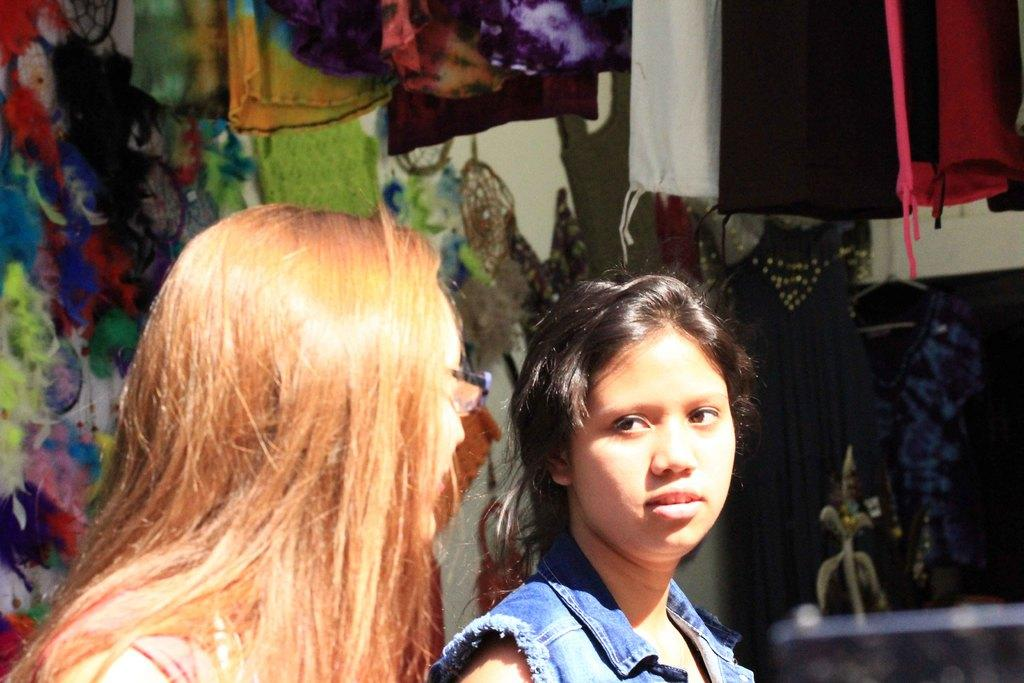How many people are in the image? There are two women in the image. What can be seen in the background of the image? There are decorative objects, clothes, and a wall in the background of the image. What type of paper is being used to create the sky in the image? There is no paper or sky present in the image; it features two women and a background with decorative objects, clothes, and a wall. 